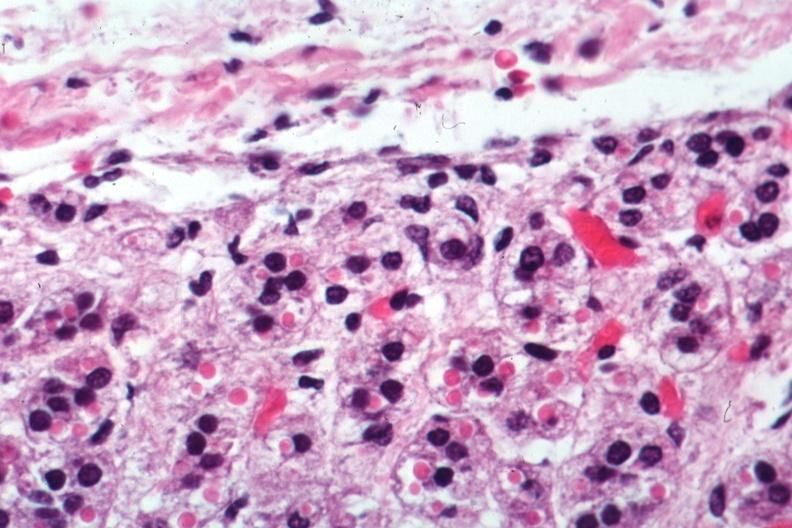does marked show excellent example?
Answer the question using a single word or phrase. No 